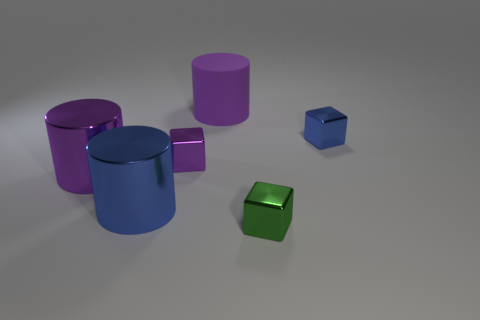Do the tiny blue object and the large purple metal thing have the same shape?
Ensure brevity in your answer.  No. The purple cube that is made of the same material as the tiny blue thing is what size?
Ensure brevity in your answer.  Small. Is the number of metal objects less than the number of big green matte cylinders?
Provide a short and direct response. No. What number of large things are either blue metal things or purple matte cylinders?
Offer a terse response. 2. How many things are both in front of the blue cube and left of the tiny green metallic object?
Provide a succinct answer. 3. Are there more small purple blocks than things?
Provide a succinct answer. No. What number of other things are the same shape as the tiny green metal thing?
Your answer should be compact. 2. What is the material of the thing that is both behind the green shiny block and in front of the large purple metallic cylinder?
Offer a terse response. Metal. The blue cylinder has what size?
Your response must be concise. Large. How many blue metallic things are behind the blue metallic thing on the left side of the purple cylinder that is behind the tiny purple object?
Provide a succinct answer. 1. 